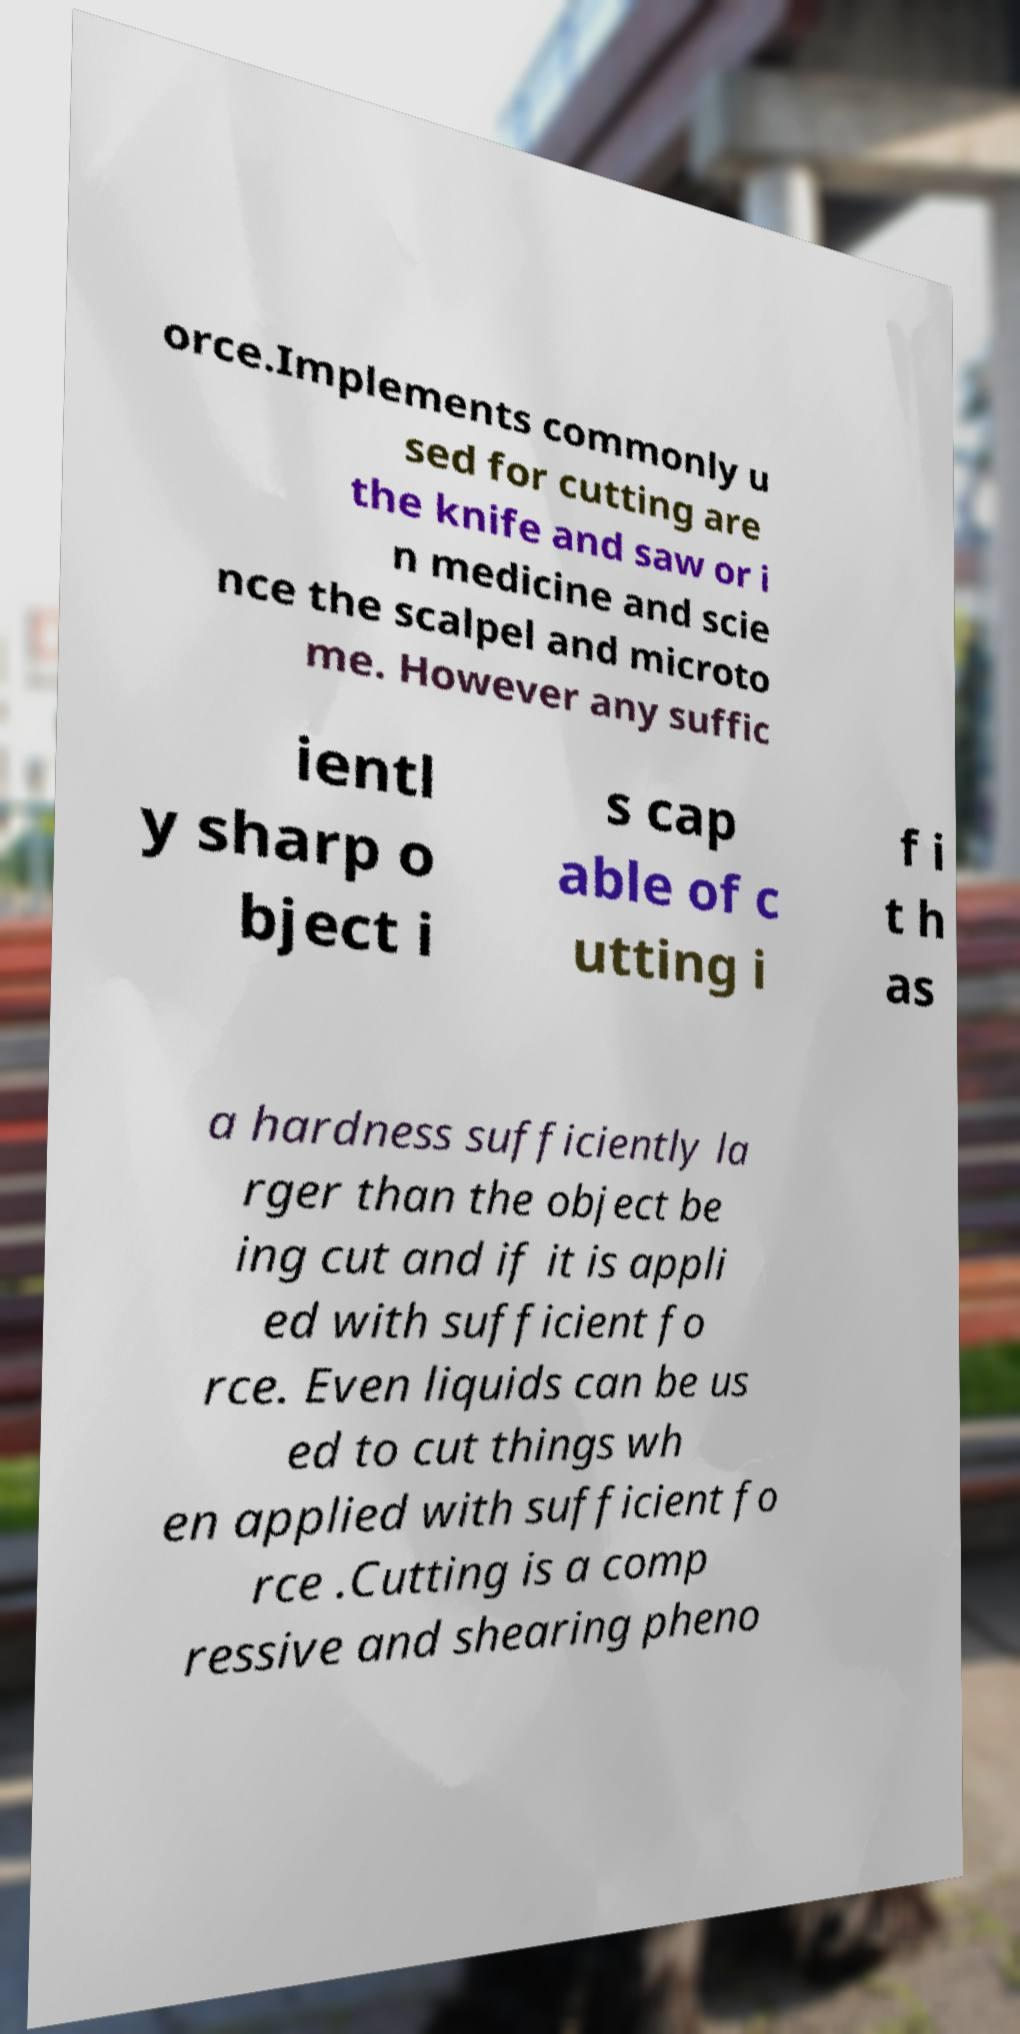For documentation purposes, I need the text within this image transcribed. Could you provide that? orce.Implements commonly u sed for cutting are the knife and saw or i n medicine and scie nce the scalpel and microto me. However any suffic ientl y sharp o bject i s cap able of c utting i f i t h as a hardness sufficiently la rger than the object be ing cut and if it is appli ed with sufficient fo rce. Even liquids can be us ed to cut things wh en applied with sufficient fo rce .Cutting is a comp ressive and shearing pheno 